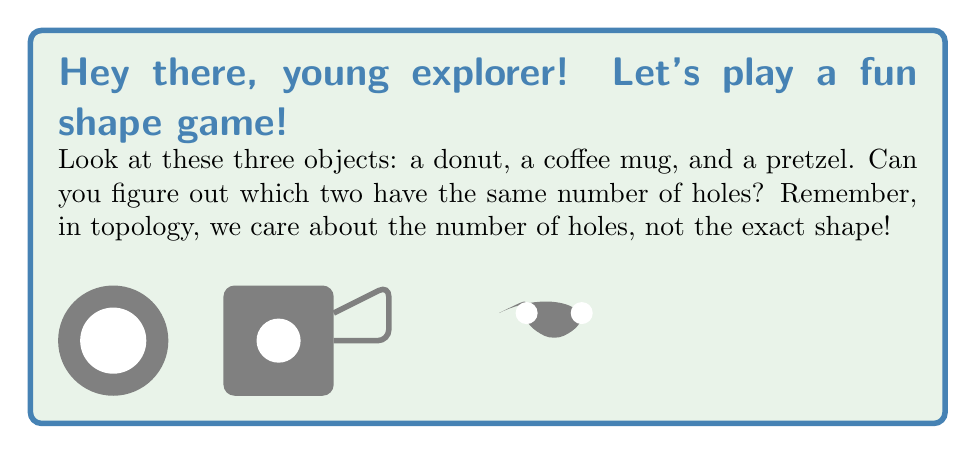Show me your answer to this math problem. Let's count the holes in each object:

1. Donut:
   The donut has one big hole in the middle. In topology, we call this a torus.
   Number of holes: $1$

2. Coffee mug:
   At first glance, you might think the coffee mug has two holes - one in the handle and one at the top. But in topology, the hole at the top of the mug is the same as the hole in the handle! If you imagine the mug made of clay, you could slowly reshape it into a donut without creating or closing any holes.
   Number of holes: $1$

3. Pretzel:
   The pretzel has two distinct holes. These holes can't be combined into one without breaking the pretzel.
   Number of holes: $2$

In topology, we focus on properties that don't change when an object is stretched, twisted, or bent (but not torn or glued). The number of holes is one such property.

The donut and the coffee mug both have one hole, making them topologically equivalent. This is a famous joke in topology: a topologist can't tell the difference between a donut and a coffee mug!

The pretzel, with its two holes, is topologically different from the other two objects.
Answer: Donut and coffee mug 